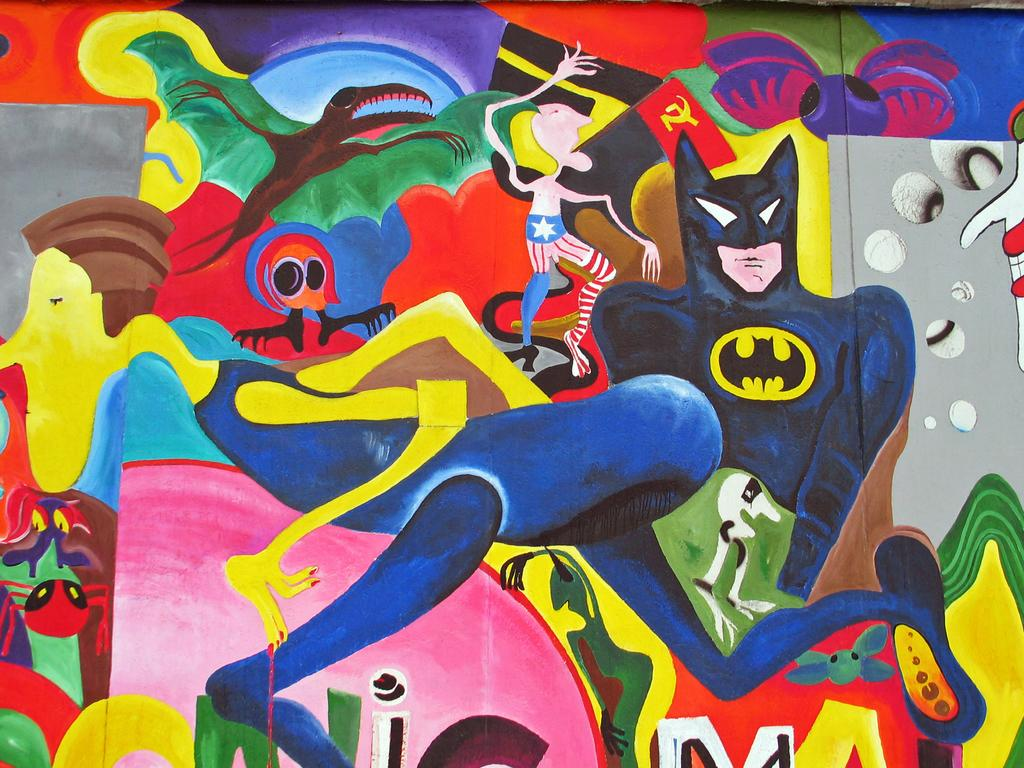What is the main subject of the poster in the image? The poster features Batman. Are there any other characters or elements on the poster? Yes, the poster includes many other cartoon characters. What can be said about the style or appearance of the poster? The poster is colorful and features a painting-like design. What type of quill is being used by the cartoon characters on the poster? There is no quill present in the image, as the poster features a painting-like design rather than a traditional drawing or illustration. 